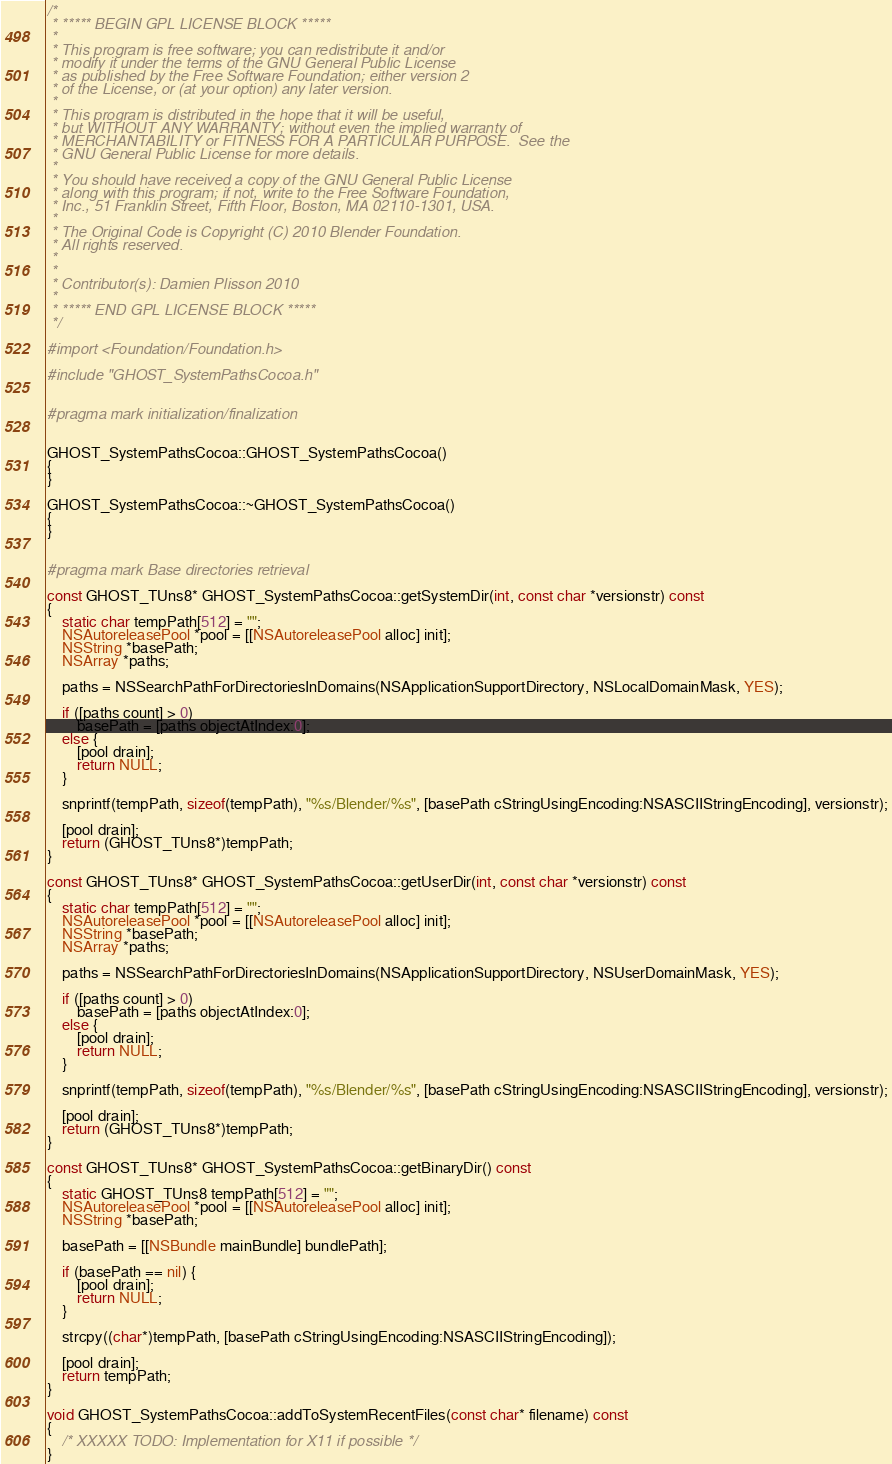<code> <loc_0><loc_0><loc_500><loc_500><_ObjectiveC_>/*
 * ***** BEGIN GPL LICENSE BLOCK *****
 *
 * This program is free software; you can redistribute it and/or
 * modify it under the terms of the GNU General Public License
 * as published by the Free Software Foundation; either version 2
 * of the License, or (at your option) any later version. 
 *
 * This program is distributed in the hope that it will be useful,
 * but WITHOUT ANY WARRANTY; without even the implied warranty of
 * MERCHANTABILITY or FITNESS FOR A PARTICULAR PURPOSE.  See the
 * GNU General Public License for more details.
 *
 * You should have received a copy of the GNU General Public License
 * along with this program; if not, write to the Free Software Foundation,
 * Inc., 51 Franklin Street, Fifth Floor, Boston, MA 02110-1301, USA.
 *
 * The Original Code is Copyright (C) 2010 Blender Foundation.
 * All rights reserved.
 *
 * 
 * Contributor(s): Damien Plisson 2010
 *
 * ***** END GPL LICENSE BLOCK *****
 */

#import <Foundation/Foundation.h>

#include "GHOST_SystemPathsCocoa.h"


#pragma mark initialization/finalization


GHOST_SystemPathsCocoa::GHOST_SystemPathsCocoa()
{
}

GHOST_SystemPathsCocoa::~GHOST_SystemPathsCocoa()
{
}


#pragma mark Base directories retrieval

const GHOST_TUns8* GHOST_SystemPathsCocoa::getSystemDir(int, const char *versionstr) const
{
	static char tempPath[512] = "";
	NSAutoreleasePool *pool = [[NSAutoreleasePool alloc] init];
	NSString *basePath;
	NSArray *paths;
	
	paths = NSSearchPathForDirectoriesInDomains(NSApplicationSupportDirectory, NSLocalDomainMask, YES);
	
	if ([paths count] > 0)
		basePath = [paths objectAtIndex:0];
	else { 
		[pool drain];
		return NULL;
	}
	
	snprintf(tempPath, sizeof(tempPath), "%s/Blender/%s", [basePath cStringUsingEncoding:NSASCIIStringEncoding], versionstr);
	
	[pool drain];
	return (GHOST_TUns8*)tempPath;
}

const GHOST_TUns8* GHOST_SystemPathsCocoa::getUserDir(int, const char *versionstr) const
{
	static char tempPath[512] = "";
	NSAutoreleasePool *pool = [[NSAutoreleasePool alloc] init];
	NSString *basePath;
	NSArray *paths;

	paths = NSSearchPathForDirectoriesInDomains(NSApplicationSupportDirectory, NSUserDomainMask, YES);

	if ([paths count] > 0)
		basePath = [paths objectAtIndex:0];
	else { 
		[pool drain];
		return NULL;
	}

	snprintf(tempPath, sizeof(tempPath), "%s/Blender/%s", [basePath cStringUsingEncoding:NSASCIIStringEncoding], versionstr);
	
	[pool drain];
	return (GHOST_TUns8*)tempPath;
}

const GHOST_TUns8* GHOST_SystemPathsCocoa::getBinaryDir() const
{
	static GHOST_TUns8 tempPath[512] = "";
	NSAutoreleasePool *pool = [[NSAutoreleasePool alloc] init];
	NSString *basePath;
	
	basePath = [[NSBundle mainBundle] bundlePath];
	
	if (basePath == nil) {
		[pool drain];
		return NULL;
	}
	
	strcpy((char*)tempPath, [basePath cStringUsingEncoding:NSASCIIStringEncoding]);
	
	[pool drain];
	return tempPath;
}

void GHOST_SystemPathsCocoa::addToSystemRecentFiles(const char* filename) const
{
	/* XXXXX TODO: Implementation for X11 if possible */
}
</code> 